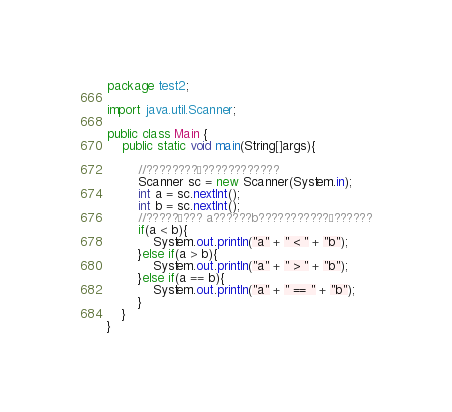<code> <loc_0><loc_0><loc_500><loc_500><_Java_>package test2;

import java.util.Scanner;

public class Main {
	public static void main(String[]args){
		
		//????????£????????????
		Scanner sc = new Scanner(System.in);
		int a = sc.nextInt();
		int b = sc.nextInt();
		//?????¶??? a??????b???????????§??????
		if(a < b){
			System.out.println("a" + " < " + "b");
		}else if(a > b){
			System.out.println("a" + " > " + "b");
		}else if(a == b){
			System.out.println("a" + " == " + "b");
		}
	}
}</code> 